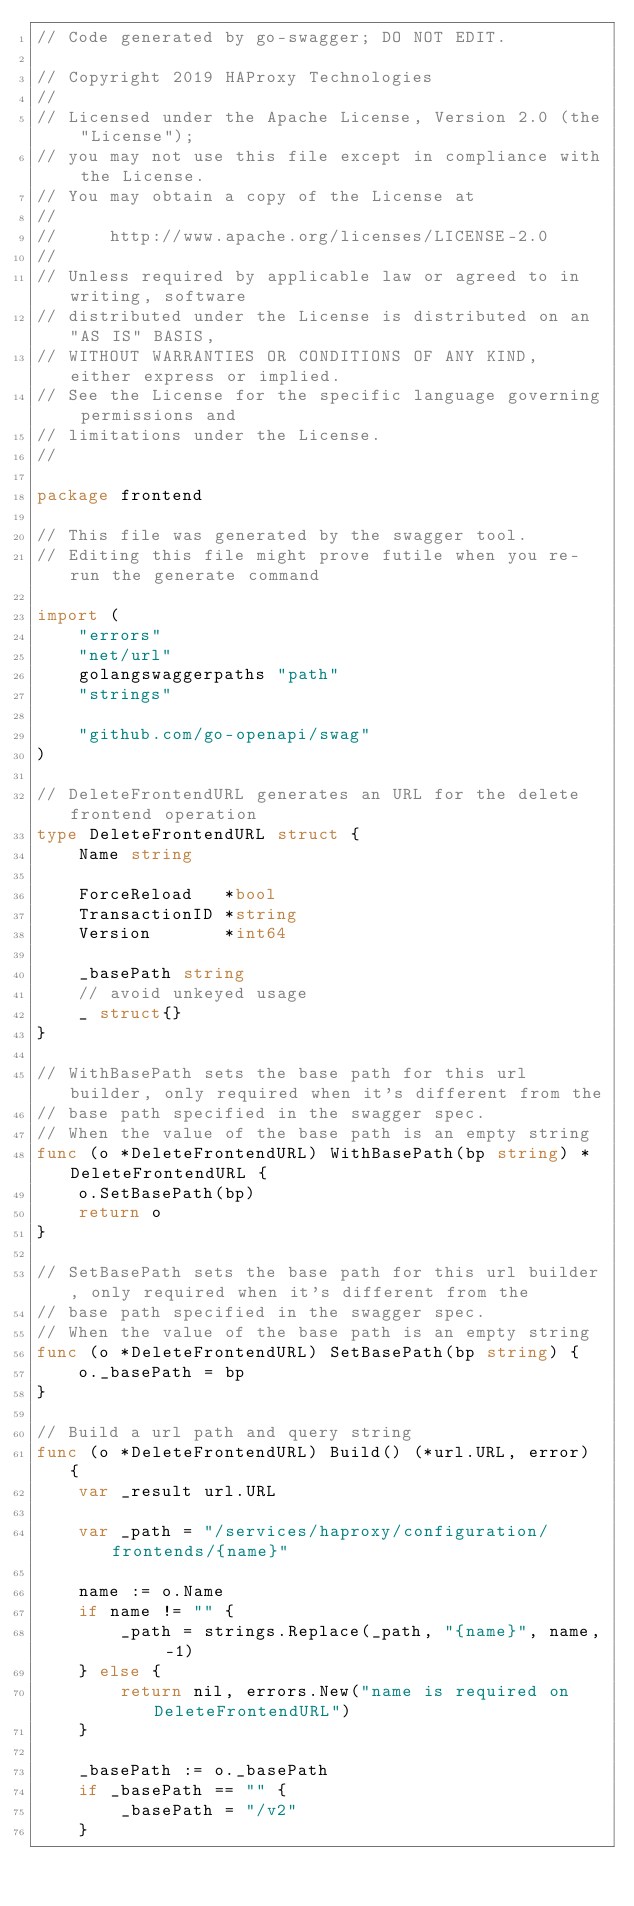Convert code to text. <code><loc_0><loc_0><loc_500><loc_500><_Go_>// Code generated by go-swagger; DO NOT EDIT.

// Copyright 2019 HAProxy Technologies
//
// Licensed under the Apache License, Version 2.0 (the "License");
// you may not use this file except in compliance with the License.
// You may obtain a copy of the License at
//
//     http://www.apache.org/licenses/LICENSE-2.0
//
// Unless required by applicable law or agreed to in writing, software
// distributed under the License is distributed on an "AS IS" BASIS,
// WITHOUT WARRANTIES OR CONDITIONS OF ANY KIND, either express or implied.
// See the License for the specific language governing permissions and
// limitations under the License.
//

package frontend

// This file was generated by the swagger tool.
// Editing this file might prove futile when you re-run the generate command

import (
	"errors"
	"net/url"
	golangswaggerpaths "path"
	"strings"

	"github.com/go-openapi/swag"
)

// DeleteFrontendURL generates an URL for the delete frontend operation
type DeleteFrontendURL struct {
	Name string

	ForceReload   *bool
	TransactionID *string
	Version       *int64

	_basePath string
	// avoid unkeyed usage
	_ struct{}
}

// WithBasePath sets the base path for this url builder, only required when it's different from the
// base path specified in the swagger spec.
// When the value of the base path is an empty string
func (o *DeleteFrontendURL) WithBasePath(bp string) *DeleteFrontendURL {
	o.SetBasePath(bp)
	return o
}

// SetBasePath sets the base path for this url builder, only required when it's different from the
// base path specified in the swagger spec.
// When the value of the base path is an empty string
func (o *DeleteFrontendURL) SetBasePath(bp string) {
	o._basePath = bp
}

// Build a url path and query string
func (o *DeleteFrontendURL) Build() (*url.URL, error) {
	var _result url.URL

	var _path = "/services/haproxy/configuration/frontends/{name}"

	name := o.Name
	if name != "" {
		_path = strings.Replace(_path, "{name}", name, -1)
	} else {
		return nil, errors.New("name is required on DeleteFrontendURL")
	}

	_basePath := o._basePath
	if _basePath == "" {
		_basePath = "/v2"
	}</code> 